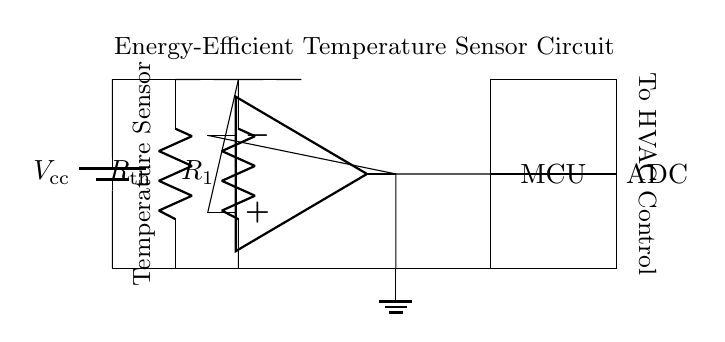What is the main component used for temperature sensing? The main component in this circuit is a thermistor, which is a type of resistor that changes resistance with temperature. In the diagram, it is labeled as \( R_{\text{th}} \).
Answer: thermistor How many resistors are present in the circuit? There are two resistors in the circuit: the thermistor \( R_{\text{th}} \) and \( R_1 \). Both are shown in the circuit diagram, each connected in a different part of the circuit.
Answer: two What is the purpose of the op-amp in this circuit? The op-amp (operational amplifier) amplifies the voltage from the voltage divider formed by the thermistor and \( R_1 \), allowing for more precise measurements. It is crucial for processing and enhancing the signal for the microcontroller.
Answer: signal amplification What is the role of the microcontroller in this circuit? The microcontroller (MCU) processes the signals received from the op-amp. It converts the analog signal into a digital form to be analyzed and possibly used for controlling other devices such as HVAC systems.
Answer: data processing What is the voltage supply labeled in the circuit? The voltage supply in the circuit is labeled \( V_{\text{cc}} \), which indicates the power source needed to operate the temperature sensor circuit. It is typically a DC voltage source.
Answer: DC voltage source In what type of applications would this temperature sensor circuit be typically used? This circuit would typically be used in applications involving environmental monitoring, such as maintaining optimal court conditions for tennis by regulating temperature and humidity.
Answer: environmental monitoring 